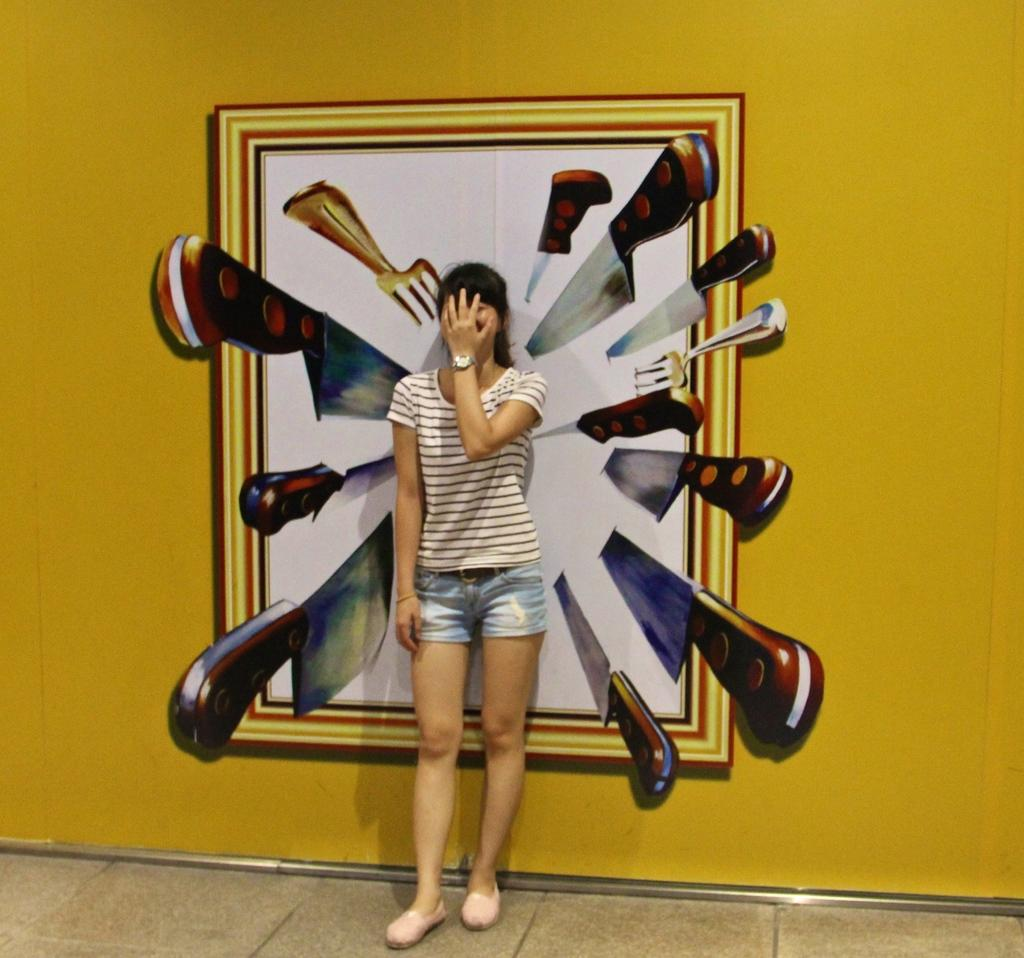What is the main subject of the image? There is a woman standing in the image. Where is the woman standing? The woman is standing on the floor. What can be seen in the background of the image? There is a wall in the background of the image. What is on the wall? There is a painting on the wall. What objects are included in the painting? The painting includes a photo frame, knives, and forks. How many crates are stacked next to the woman in the image? There are no crates visible in the image; the focus is on the woman, the wall, and the painting. Can you see a kitty playing with the forks in the painting? There is no kitty present in the image, either in the painting or in the room with the woman. 